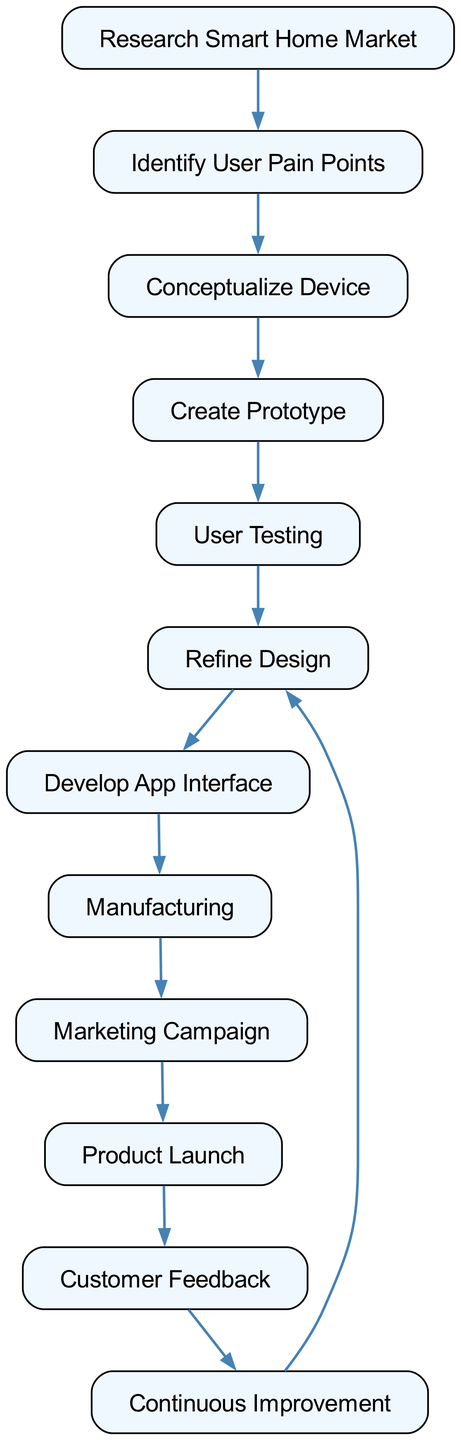What is the first step in the user experience journey? The first step is "Research Smart Home Market," as indicated by the starting node of the directed graph.
Answer: Research Smart Home Market How many nodes are present in the diagram? By counting each unique step or stage in the user experience journey listed in the diagram, we find there are twelve nodes.
Answer: 12 What follows after "User Testing"? The next step, as indicated by the directed edge leading from "User Testing," is "Refine Design."
Answer: Refine Design What is the last step in the journey? The last node in the directed graph, where flow ends, is "Continuous Improvement."
Answer: Continuous Improvement Which node is directly connected to both "Manufacturing" and "Customer Feedback"? Upon inspecting the diagram, it can be identified that "Marketing Campaign" is the node directly connected to "Manufacturing," and "Product Launch" is directly linked to "Customer Feedback," confirming that no node fulfills both conditions.
Answer: None How many total edges are there in the diagram? By counting the connections (edges) between the pairs of nodes, we can conclude that there are eleven edges in total.
Answer: 11 Which phase leads to "Develop App Interface"? The phase that directly leads to "Develop App Interface" is "Refine Design," as per the directed connection in the diagram.
Answer: Refine Design Which step comes immediately after "Product Launch"? The step that directly follows "Product Launch," based on the directed edge in the diagram, is "Customer Feedback."
Answer: Customer Feedback What is the connection between "Identifying User Pain Points" and "Creating Prototype"? The connection is that "Identify User Pain Points" leads to "Conceptualize Device," which in turn leads to "Create Prototype," indicating a sequential flow from identifying pain points to creating a prototype.
Answer: Sequential flow 